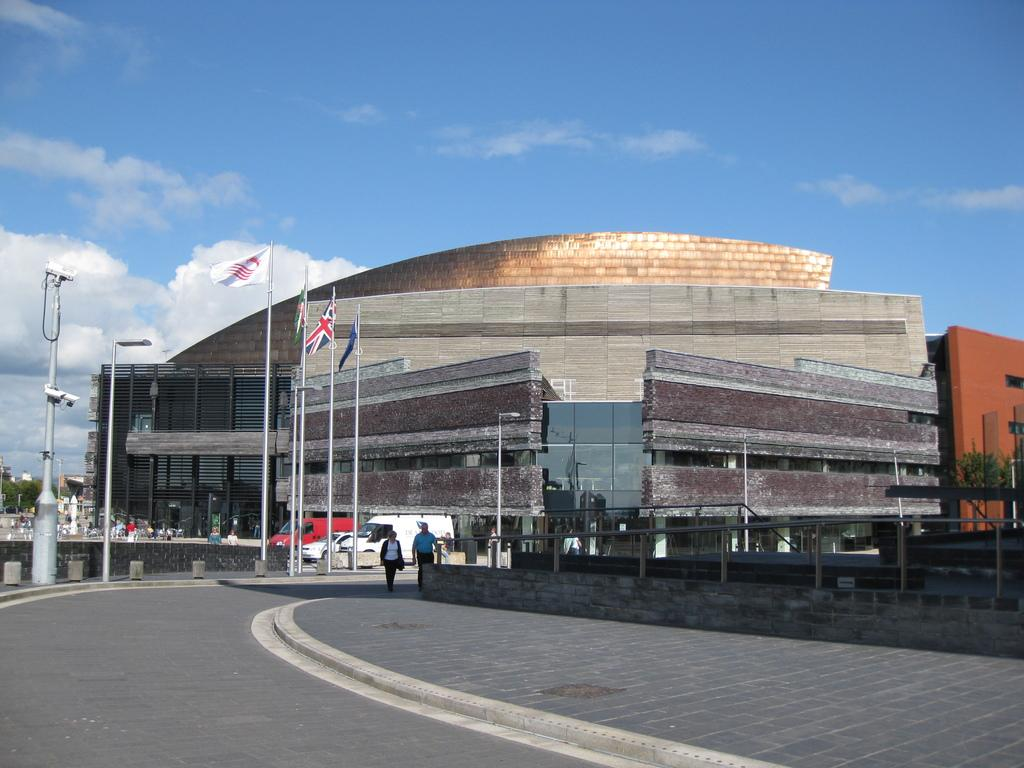What type of structures can be seen in the image? There are buildings in the image. What are the people in the image doing? There are persons walking on the road in the image. What devices are used for surveillance in the image? CCTV cameras are present in the image. How are the flags displayed in the image? Flags are attached to flag posts in the image. What type of poles are visible in the image? Street poles are visible in the image. What type of lighting is present in the image? Street lights are present in the image. What type of vegetation is in the image? Trees are in the image. What is visible in the background of the image? The sky is visible in the background of the image. What can be seen in the sky in the image? Clouds are present in the sky in the image. What type of business is being rewarded in the image? There is no business or reward present in the image; it features buildings, persons walking, CCTV cameras, flags, street poles, street lights, trees, and a sky with clouds. 